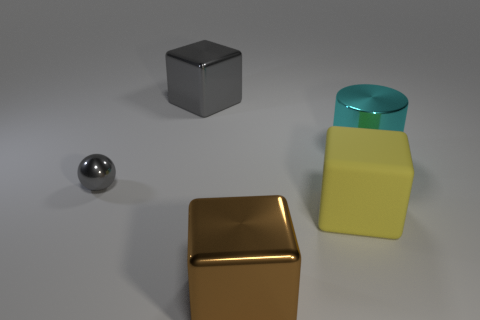Is the big yellow matte object the same shape as the brown thing?
Make the answer very short. Yes. How many other things are there of the same size as the cyan cylinder?
Offer a very short reply. 3. The small object is what color?
Your response must be concise. Gray. There is a object behind the cyan cylinder; what is its material?
Give a very brief answer. Metal. Does the big yellow thing have the same shape as the big object in front of the yellow rubber object?
Keep it short and to the point. Yes. Is the number of large rubber objects greater than the number of brown shiny balls?
Offer a terse response. Yes. Is there anything else that has the same color as the metallic ball?
Ensure brevity in your answer.  Yes. The big gray object that is the same material as the cyan cylinder is what shape?
Offer a very short reply. Cube. There is a large block that is on the left side of the block that is in front of the yellow rubber cube; what is its material?
Provide a succinct answer. Metal. There is a metallic thing that is on the right side of the large brown cube; is its shape the same as the big brown thing?
Keep it short and to the point. No. 